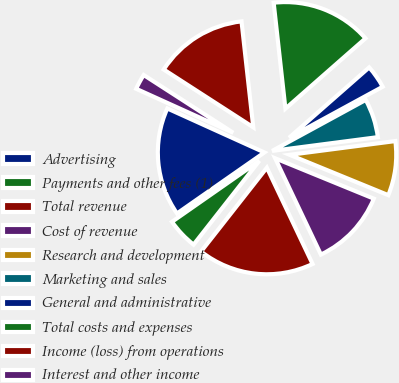Convert chart. <chart><loc_0><loc_0><loc_500><loc_500><pie_chart><fcel>Advertising<fcel>Payments and other fees (1)<fcel>Total revenue<fcel>Cost of revenue<fcel>Research and development<fcel>Marketing and sales<fcel>General and administrative<fcel>Total costs and expenses<fcel>Income (loss) from operations<fcel>Interest and other income<nl><fcel>16.47%<fcel>4.71%<fcel>17.65%<fcel>11.76%<fcel>8.24%<fcel>5.88%<fcel>3.53%<fcel>15.29%<fcel>14.12%<fcel>2.35%<nl></chart> 